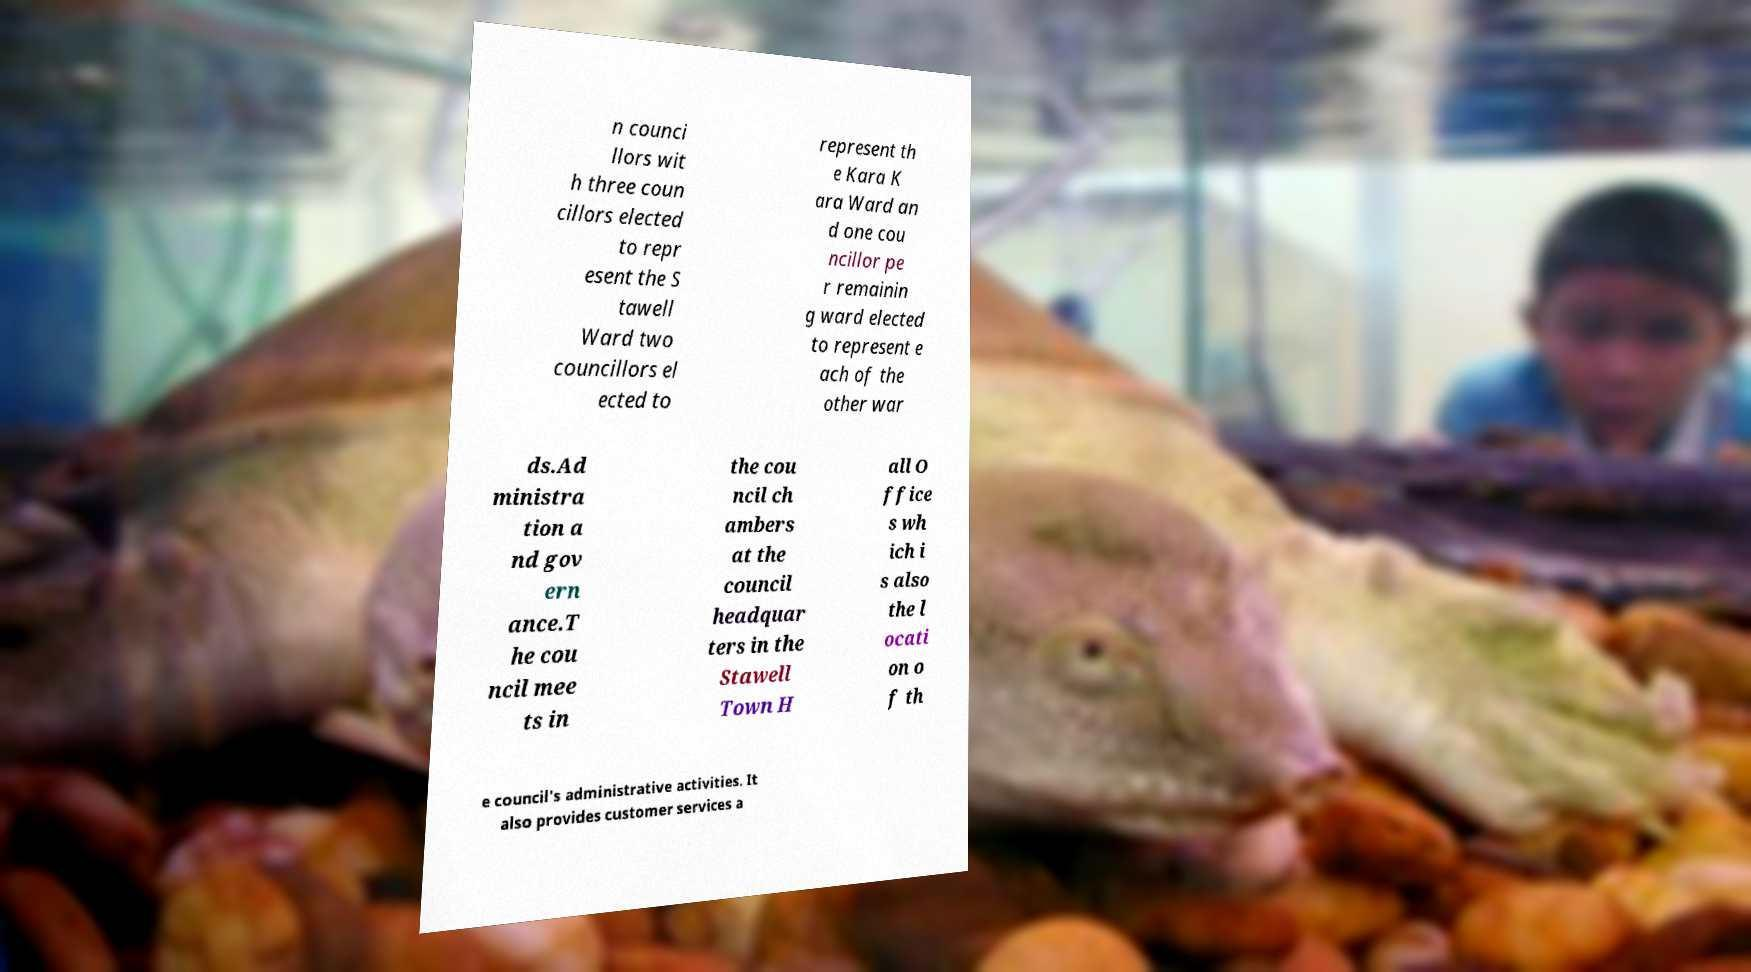I need the written content from this picture converted into text. Can you do that? n counci llors wit h three coun cillors elected to repr esent the S tawell Ward two councillors el ected to represent th e Kara K ara Ward an d one cou ncillor pe r remainin g ward elected to represent e ach of the other war ds.Ad ministra tion a nd gov ern ance.T he cou ncil mee ts in the cou ncil ch ambers at the council headquar ters in the Stawell Town H all O ffice s wh ich i s also the l ocati on o f th e council's administrative activities. It also provides customer services a 